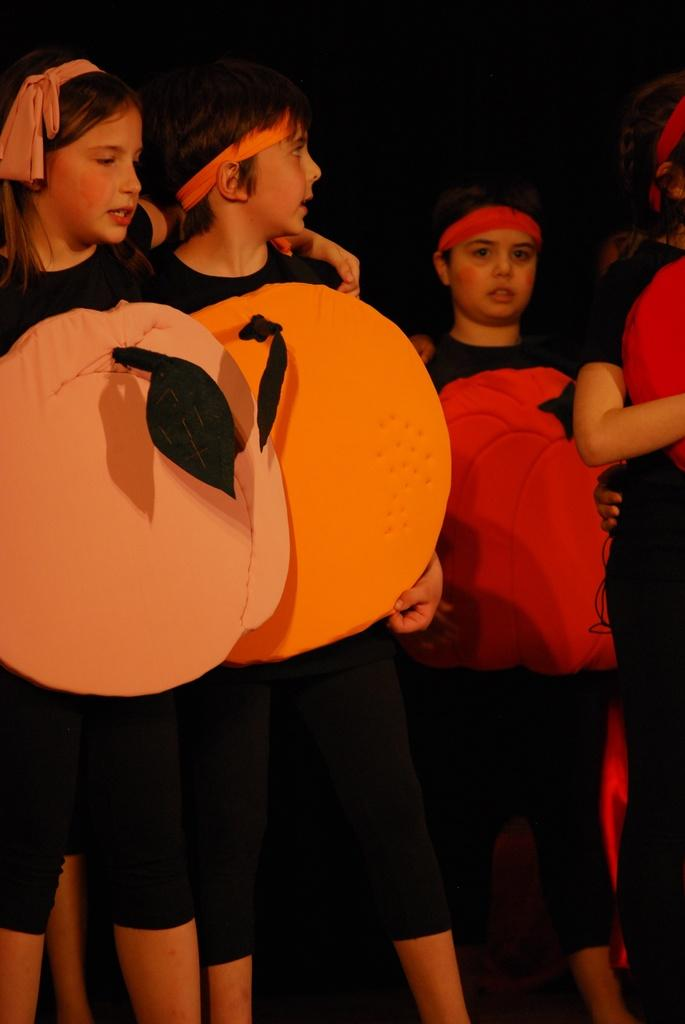How many people are in the image? There are four persons in the image. What are the persons wearing? The persons are wearing fancy dresses. Can you describe the background of the image? The background of the image is dark. Can you see a flock of squirrels playing in the snow in the image? There is no snow or squirrels present in the image; it features four persons wearing fancy dresses with a dark background. 